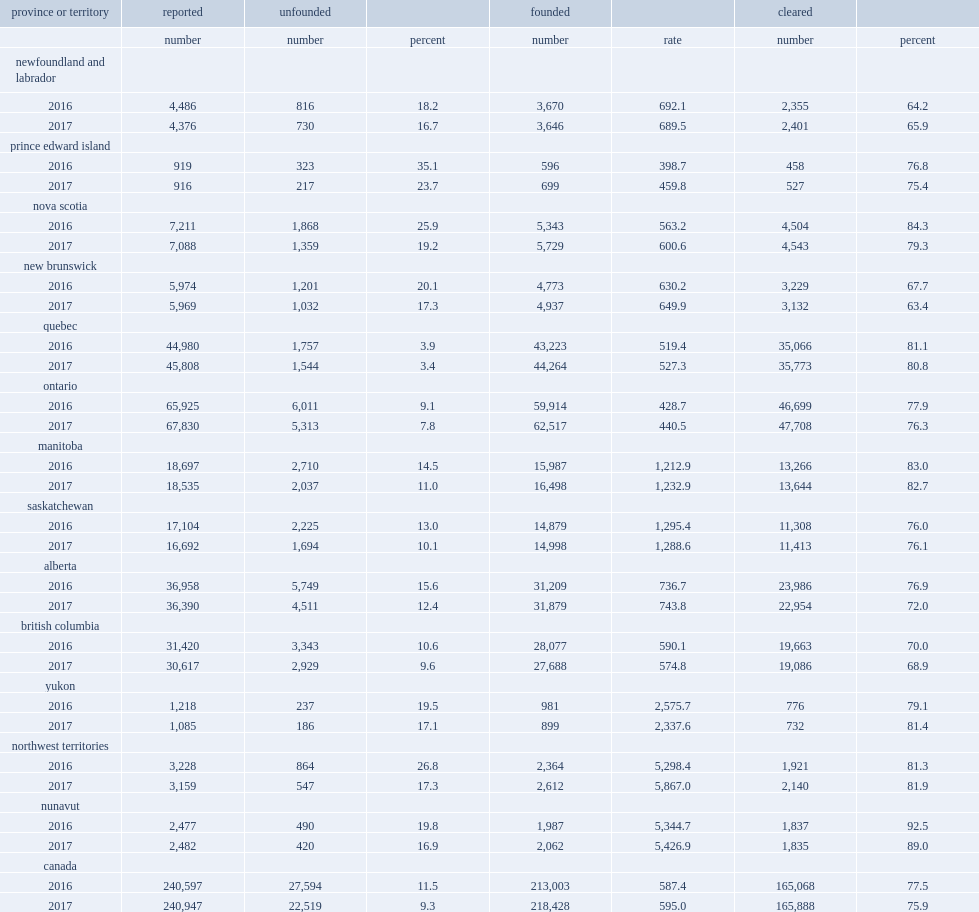What were the percentages of physical assaults (levels 1, 2, and 3) classified as unfounded in 2016 and 2017 respectively? 11.5 9.3. List the top3 provinces and territories with the greatest decrease. Prince edward island nova scotia manitoba. Parse the table in full. {'header': ['province or territory', 'reported', 'unfounded', '', 'founded', '', 'cleared', ''], 'rows': [['', 'number', 'number', 'percent', 'number', 'rate', 'number', 'percent'], ['newfoundland and labrador', '', '', '', '', '', '', ''], ['2016', '4,486', '816', '18.2', '3,670', '692.1', '2,355', '64.2'], ['2017', '4,376', '730', '16.7', '3,646', '689.5', '2,401', '65.9'], ['prince edward island', '', '', '', '', '', '', ''], ['2016', '919', '323', '35.1', '596', '398.7', '458', '76.8'], ['2017', '916', '217', '23.7', '699', '459.8', '527', '75.4'], ['nova scotia', '', '', '', '', '', '', ''], ['2016', '7,211', '1,868', '25.9', '5,343', '563.2', '4,504', '84.3'], ['2017', '7,088', '1,359', '19.2', '5,729', '600.6', '4,543', '79.3'], ['new brunswick', '', '', '', '', '', '', ''], ['2016', '5,974', '1,201', '20.1', '4,773', '630.2', '3,229', '67.7'], ['2017', '5,969', '1,032', '17.3', '4,937', '649.9', '3,132', '63.4'], ['quebec', '', '', '', '', '', '', ''], ['2016', '44,980', '1,757', '3.9', '43,223', '519.4', '35,066', '81.1'], ['2017', '45,808', '1,544', '3.4', '44,264', '527.3', '35,773', '80.8'], ['ontario', '', '', '', '', '', '', ''], ['2016', '65,925', '6,011', '9.1', '59,914', '428.7', '46,699', '77.9'], ['2017', '67,830', '5,313', '7.8', '62,517', '440.5', '47,708', '76.3'], ['manitoba', '', '', '', '', '', '', ''], ['2016', '18,697', '2,710', '14.5', '15,987', '1,212.9', '13,266', '83.0'], ['2017', '18,535', '2,037', '11.0', '16,498', '1,232.9', '13,644', '82.7'], ['saskatchewan', '', '', '', '', '', '', ''], ['2016', '17,104', '2,225', '13.0', '14,879', '1,295.4', '11,308', '76.0'], ['2017', '16,692', '1,694', '10.1', '14,998', '1,288.6', '11,413', '76.1'], ['alberta', '', '', '', '', '', '', ''], ['2016', '36,958', '5,749', '15.6', '31,209', '736.7', '23,986', '76.9'], ['2017', '36,390', '4,511', '12.4', '31,879', '743.8', '22,954', '72.0'], ['british columbia', '', '', '', '', '', '', ''], ['2016', '31,420', '3,343', '10.6', '28,077', '590.1', '19,663', '70.0'], ['2017', '30,617', '2,929', '9.6', '27,688', '574.8', '19,086', '68.9'], ['yukon', '', '', '', '', '', '', ''], ['2016', '1,218', '237', '19.5', '981', '2,575.7', '776', '79.1'], ['2017', '1,085', '186', '17.1', '899', '2,337.6', '732', '81.4'], ['northwest territories', '', '', '', '', '', '', ''], ['2016', '3,228', '864', '26.8', '2,364', '5,298.4', '1,921', '81.3'], ['2017', '3,159', '547', '17.3', '2,612', '5,867.0', '2,140', '81.9'], ['nunavut', '', '', '', '', '', '', ''], ['2016', '2,477', '490', '19.8', '1,987', '5,344.7', '1,837', '92.5'], ['2017', '2,482', '420', '16.9', '2,062', '5,426.9', '1,835', '89.0'], ['canada', '', '', '', '', '', '', ''], ['2016', '240,597', '27,594', '11.5', '213,003', '587.4', '165,068', '77.5'], ['2017', '240,947', '22,519', '9.3', '218,428', '595.0', '165,888', '75.9']]} 